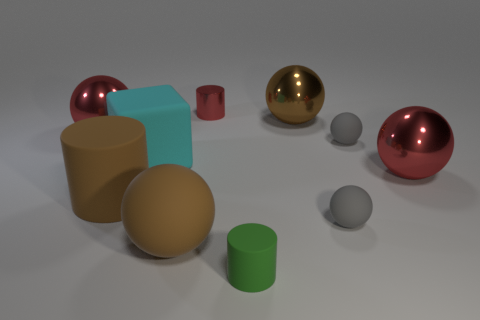There is a thing that is behind the cyan cube and on the left side of the cyan rubber object; what is its shape? sphere 